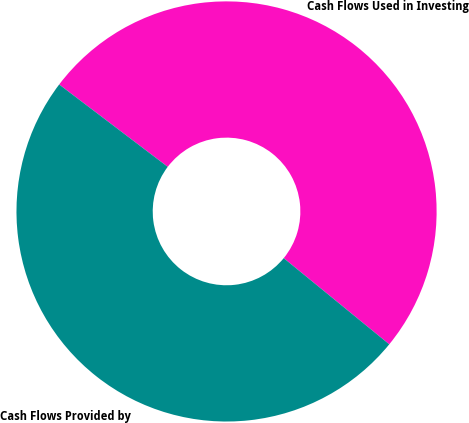Convert chart. <chart><loc_0><loc_0><loc_500><loc_500><pie_chart><fcel>Cash Flows Used in Investing<fcel>Cash Flows Provided by<nl><fcel>50.57%<fcel>49.43%<nl></chart> 